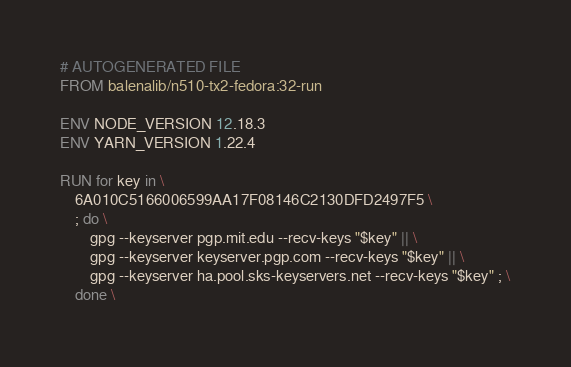Convert code to text. <code><loc_0><loc_0><loc_500><loc_500><_Dockerfile_># AUTOGENERATED FILE
FROM balenalib/n510-tx2-fedora:32-run

ENV NODE_VERSION 12.18.3
ENV YARN_VERSION 1.22.4

RUN for key in \
	6A010C5166006599AA17F08146C2130DFD2497F5 \
	; do \
		gpg --keyserver pgp.mit.edu --recv-keys "$key" || \
		gpg --keyserver keyserver.pgp.com --recv-keys "$key" || \
		gpg --keyserver ha.pool.sks-keyservers.net --recv-keys "$key" ; \
	done \</code> 